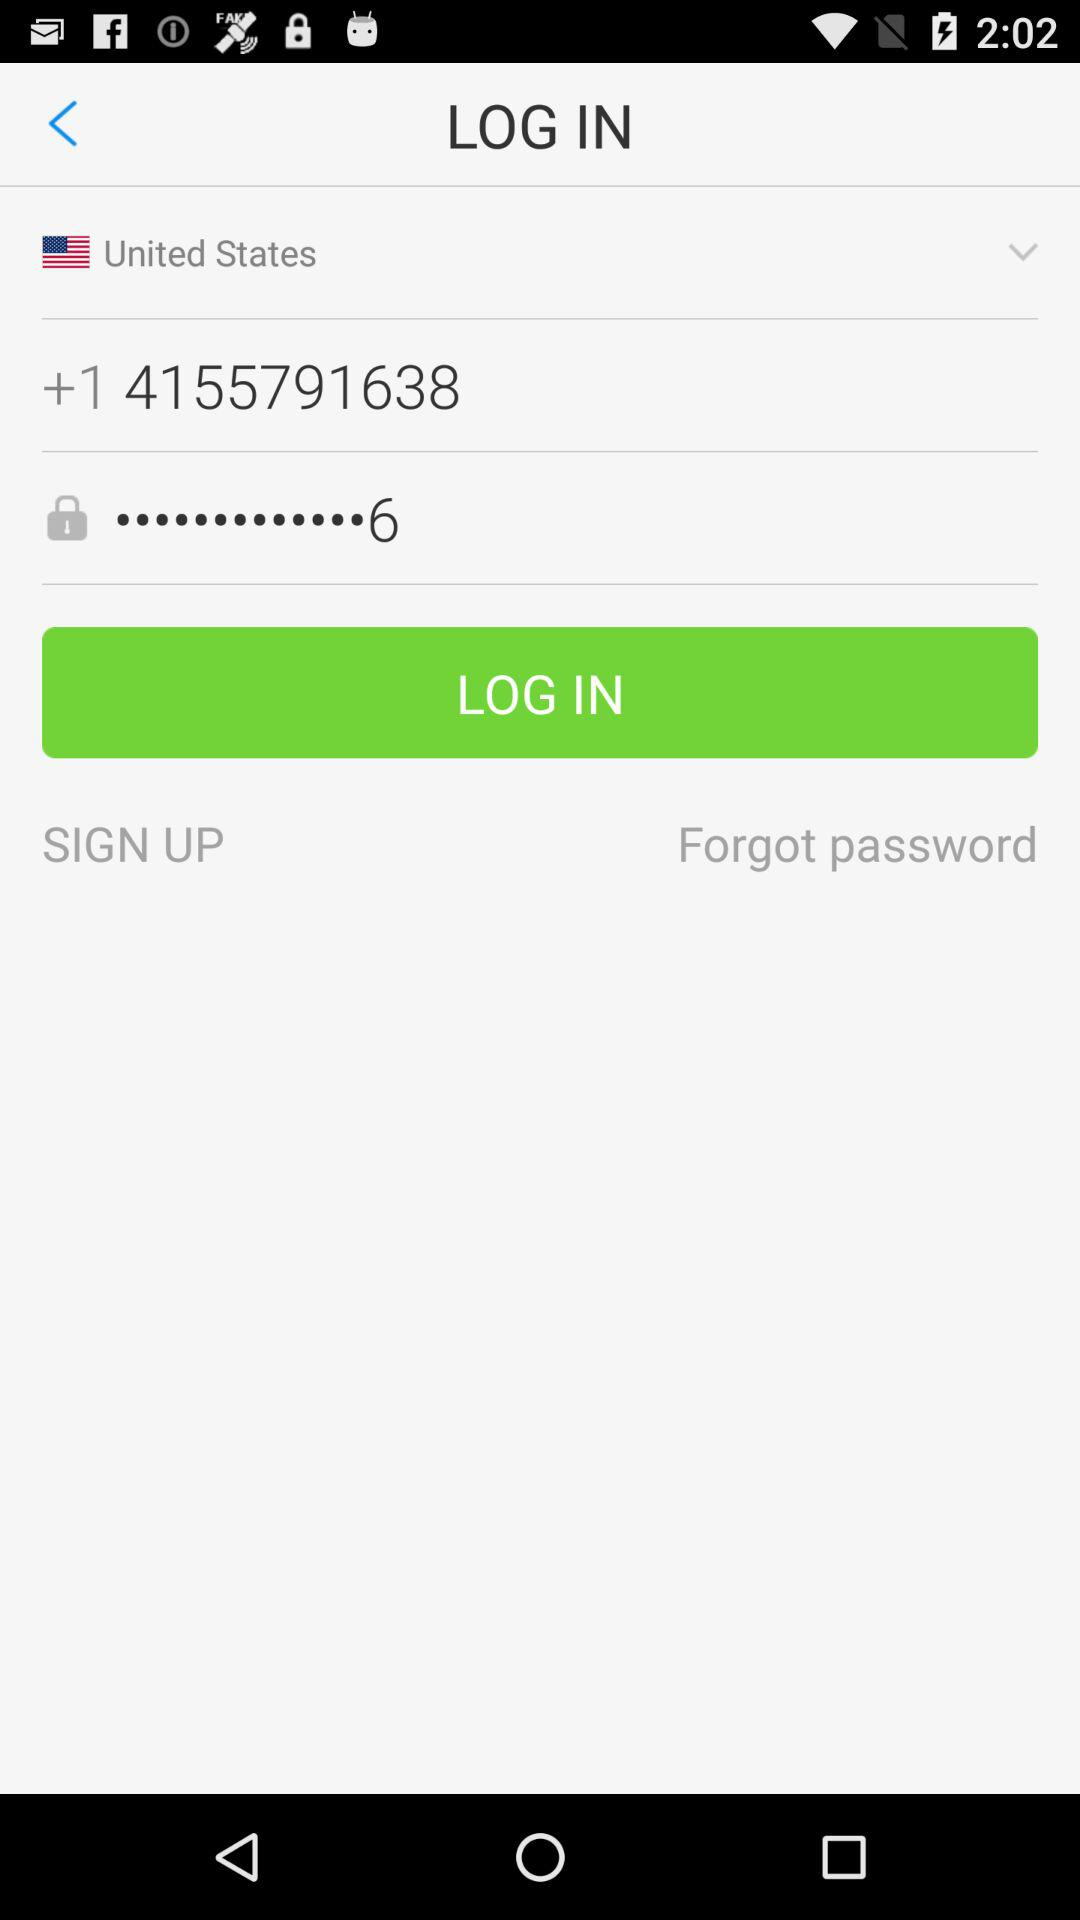What is the last digit of the password shown? The last digit of the password shown is 6. 